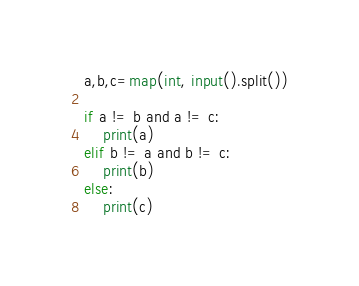Convert code to text. <code><loc_0><loc_0><loc_500><loc_500><_Python_>a,b,c=map(int, input().split())

if a != b and a != c:
    print(a)
elif b != a and b != c:
    print(b)
else:
    print(c)
</code> 